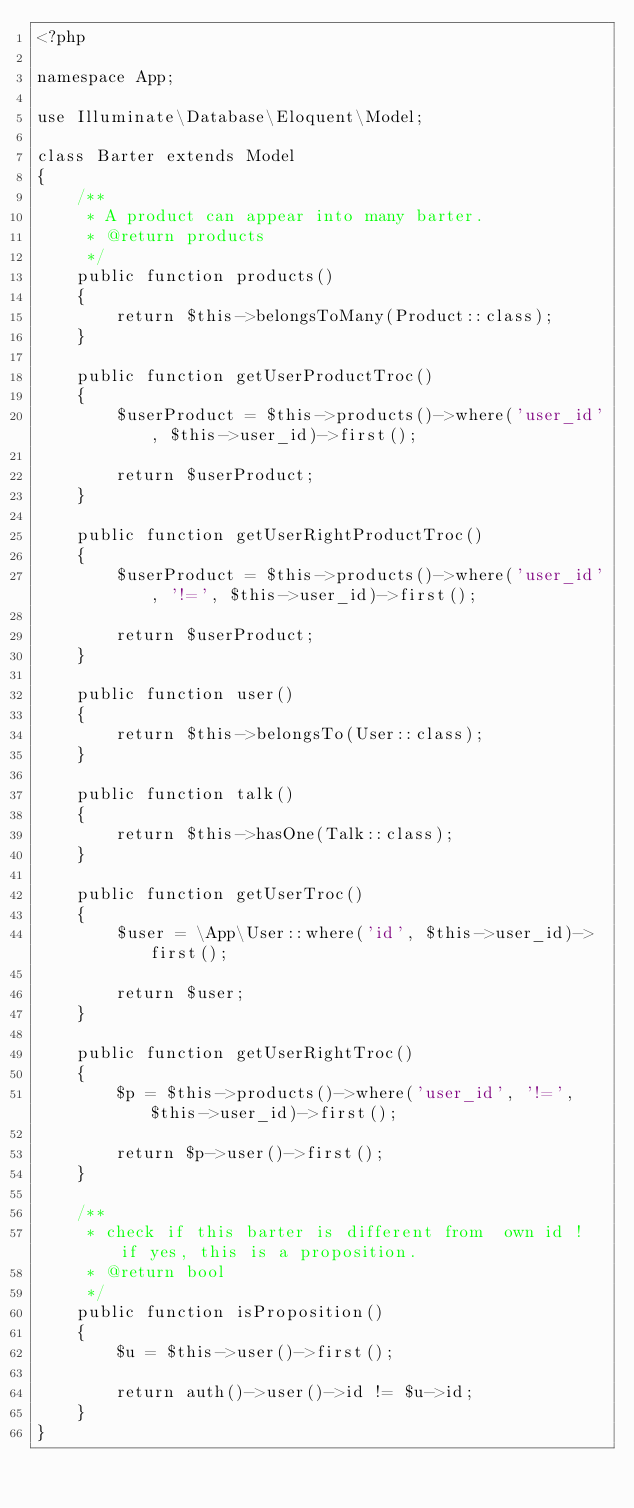<code> <loc_0><loc_0><loc_500><loc_500><_PHP_><?php

namespace App;

use Illuminate\Database\Eloquent\Model;

class Barter extends Model
{
    /**
     * A product can appear into many barter.
     * @return products
     */
    public function products()
    {
        return $this->belongsToMany(Product::class);
    }

    public function getUserProductTroc()
    {
        $userProduct = $this->products()->where('user_id', $this->user_id)->first();

        return $userProduct;
    }

    public function getUserRightProductTroc()
    {
        $userProduct = $this->products()->where('user_id', '!=', $this->user_id)->first();

        return $userProduct;
    }

    public function user()
    {
        return $this->belongsTo(User::class);
    }

    public function talk()
    {
        return $this->hasOne(Talk::class);
    }

    public function getUserTroc()
    {
        $user = \App\User::where('id', $this->user_id)->first();

        return $user;
    }

    public function getUserRightTroc()
    {
        $p = $this->products()->where('user_id', '!=', $this->user_id)->first();

        return $p->user()->first();
    }

    /**
     * check if this barter is different from  own id ! if yes, this is a proposition.
     * @return bool
     */
    public function isProposition()
    {
        $u = $this->user()->first();

        return auth()->user()->id != $u->id;
    }
}
</code> 